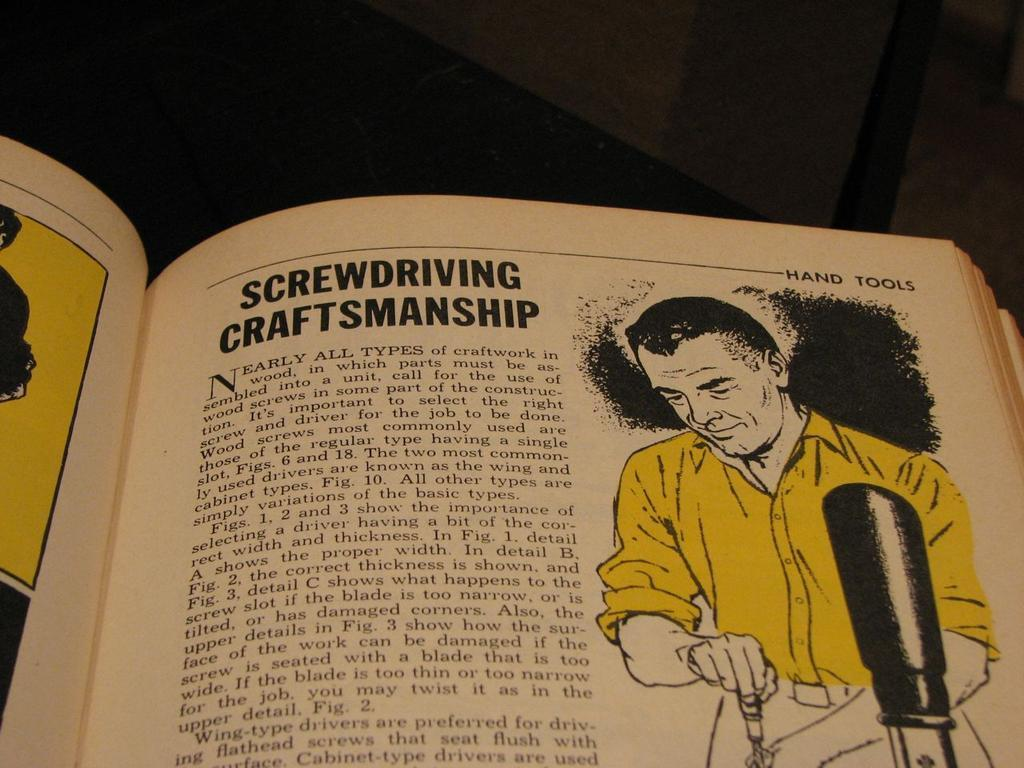Provide a one-sentence caption for the provided image. An article in an old book about Screwdriving Craftsmanship. 